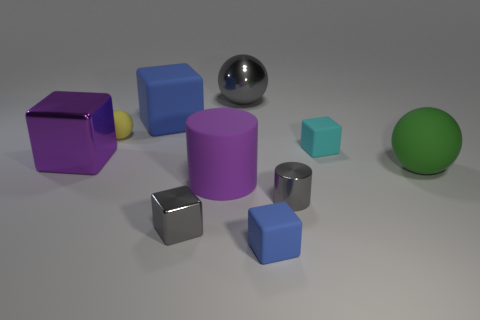Subtract all large shiny balls. How many balls are left? 2 Subtract all gray cylinders. How many cylinders are left? 1 Subtract all balls. How many objects are left? 7 Subtract all green cylinders. Subtract all brown balls. How many cylinders are left? 2 Subtract all cyan spheres. How many cyan cubes are left? 1 Subtract all small yellow matte objects. Subtract all cyan things. How many objects are left? 8 Add 1 big things. How many big things are left? 6 Add 6 rubber cubes. How many rubber cubes exist? 9 Subtract 0 blue cylinders. How many objects are left? 10 Subtract 2 cubes. How many cubes are left? 3 